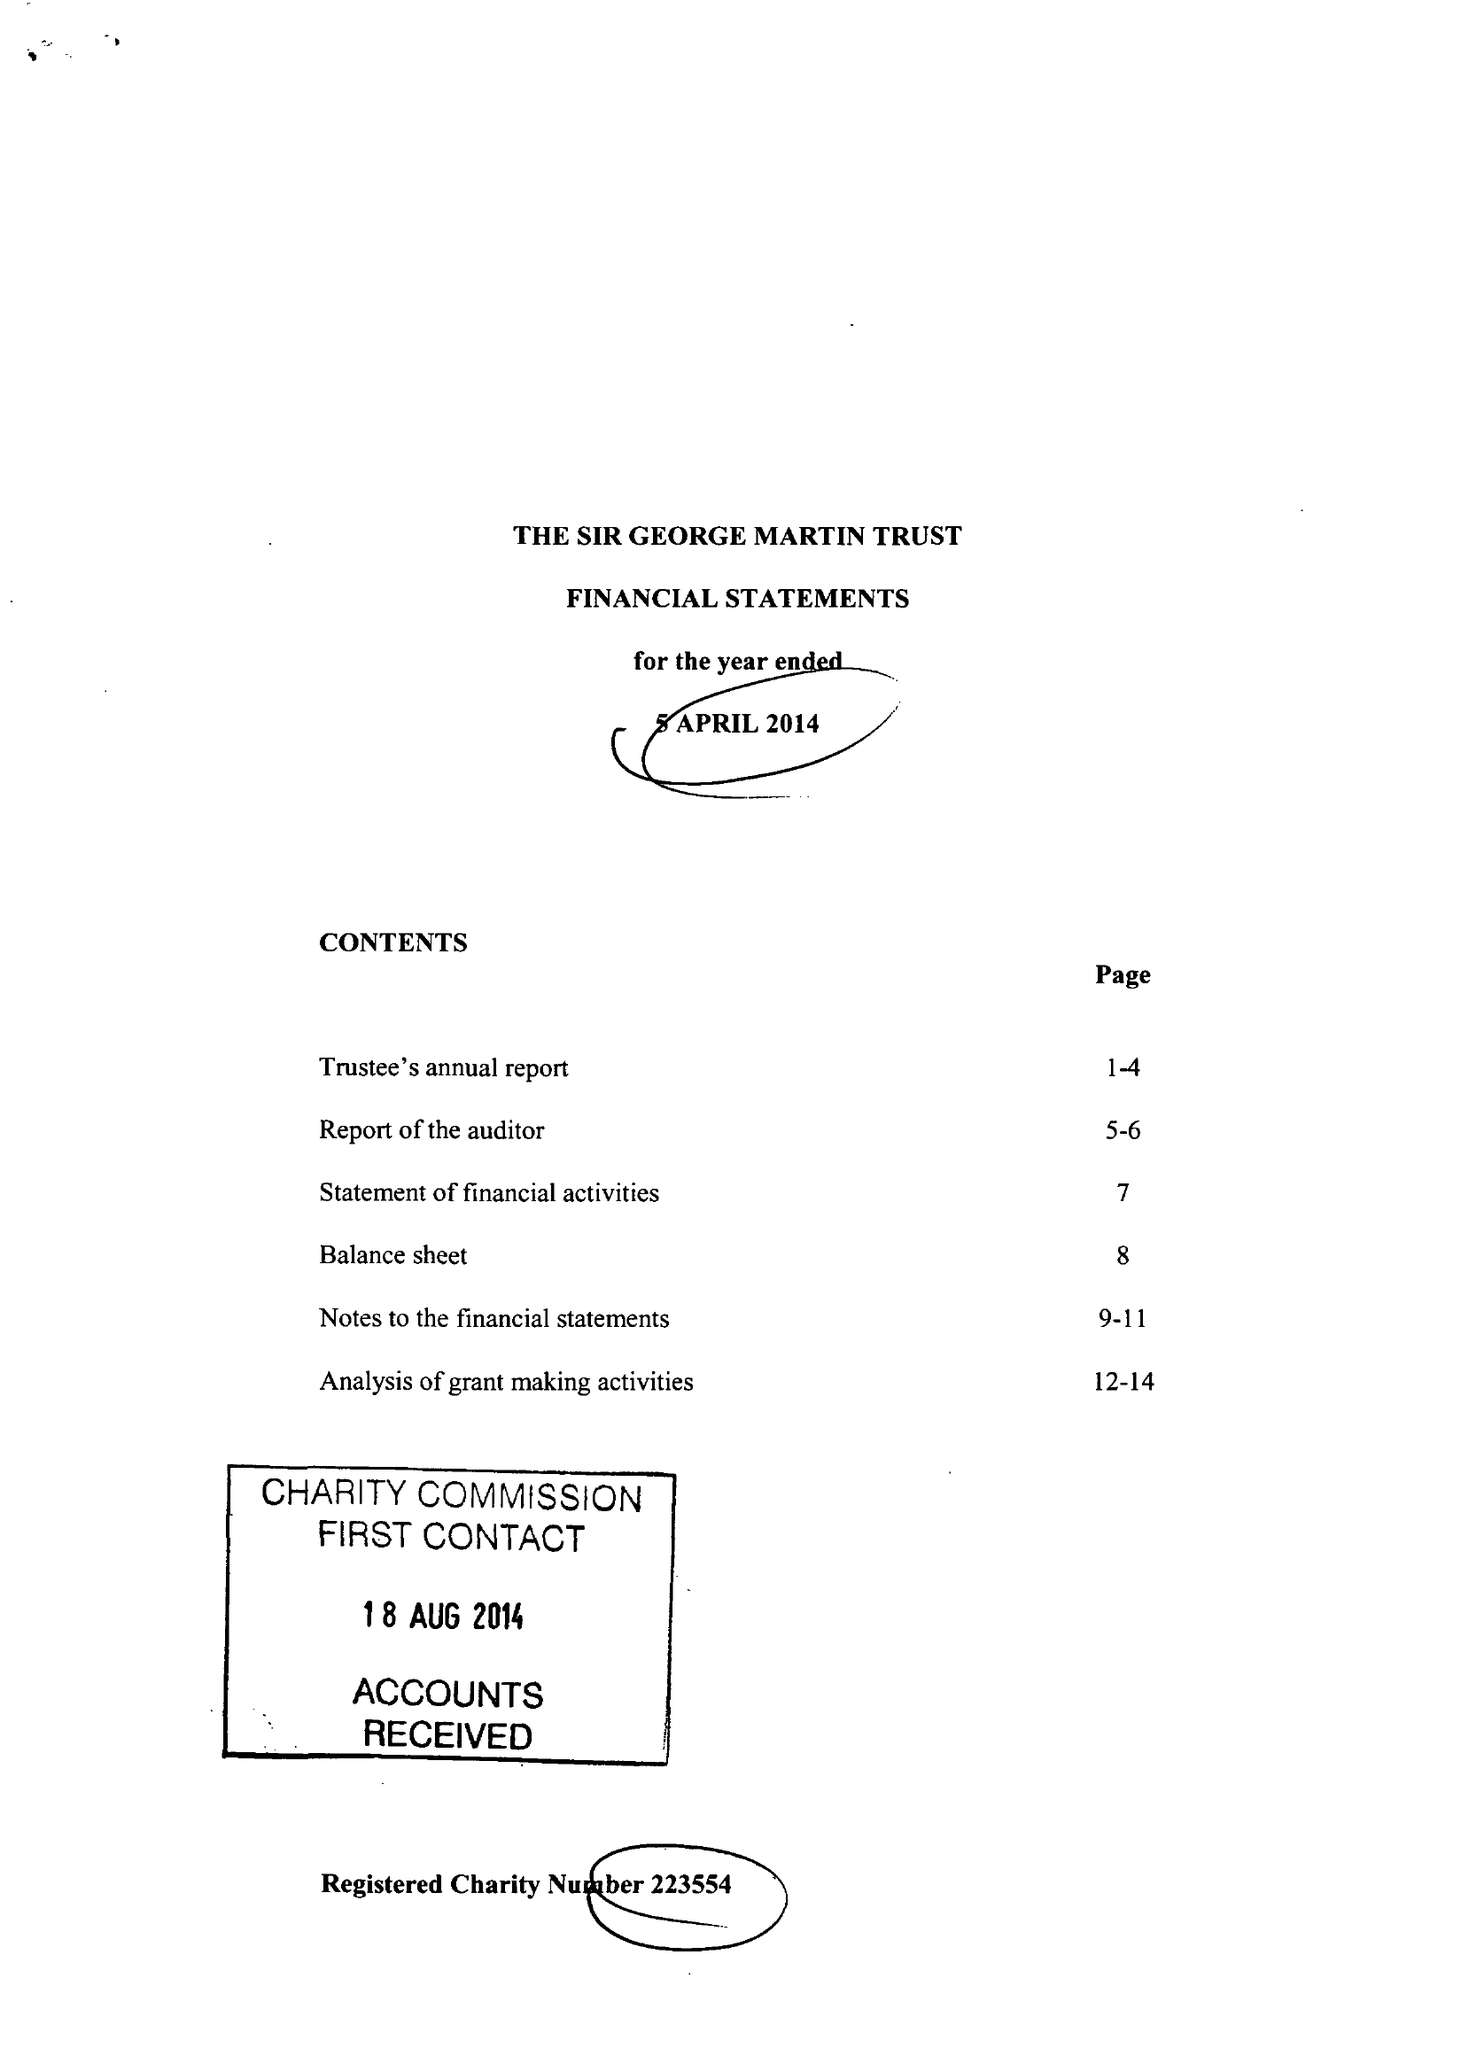What is the value for the report_date?
Answer the question using a single word or phrase. 2014-04-05 